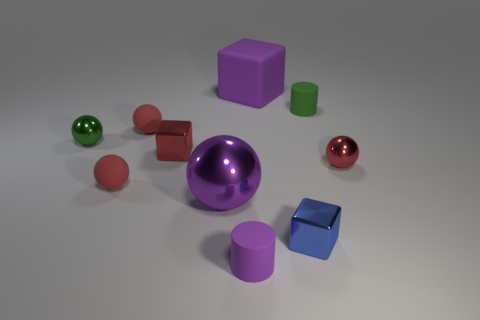Does the purple object that is to the right of the purple cylinder have the same size as the purple ball?
Offer a very short reply. Yes. Is there a tiny matte ball of the same color as the big ball?
Ensure brevity in your answer.  No. The purple cube that is the same material as the purple cylinder is what size?
Keep it short and to the point. Large. Are there more blue metal cubes in front of the big matte block than tiny matte balls that are to the right of the large metallic sphere?
Give a very brief answer. Yes. How many other objects are there of the same material as the large sphere?
Your answer should be compact. 4. Is the purple object behind the green shiny object made of the same material as the red block?
Your answer should be compact. No. What shape is the green rubber thing?
Offer a terse response. Cylinder. Is the number of small red spheres that are to the right of the purple sphere greater than the number of blue matte spheres?
Keep it short and to the point. Yes. What color is the other small object that is the same shape as the blue thing?
Provide a short and direct response. Red. The purple matte object that is in front of the small blue object has what shape?
Your response must be concise. Cylinder. 